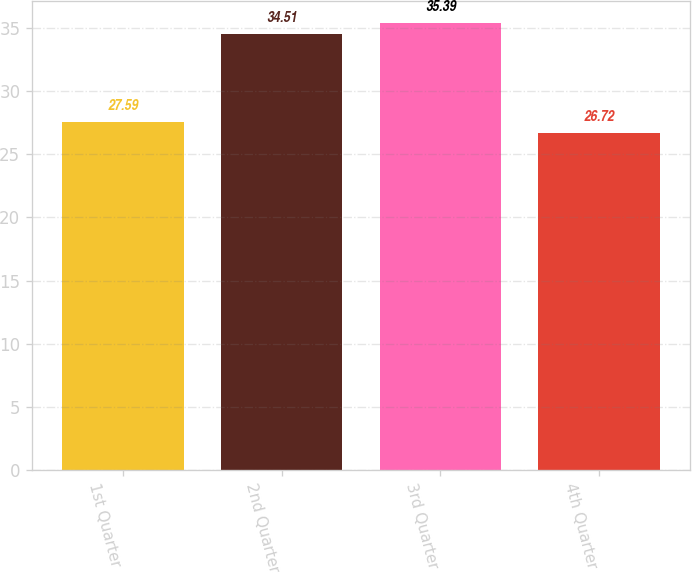Convert chart to OTSL. <chart><loc_0><loc_0><loc_500><loc_500><bar_chart><fcel>1st Quarter<fcel>2nd Quarter<fcel>3rd Quarter<fcel>4th Quarter<nl><fcel>27.59<fcel>34.51<fcel>35.39<fcel>26.72<nl></chart> 